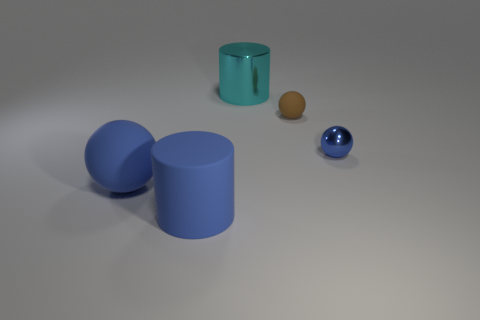There is a rubber object that is the same color as the rubber cylinder; what is its shape?
Provide a short and direct response. Sphere. The blue matte object that is right of the blue thing that is left of the big blue rubber cylinder is what shape?
Provide a succinct answer. Cylinder. Is there anything else that is the same color as the tiny rubber object?
Your answer should be very brief. No. Is the color of the small shiny ball the same as the large rubber ball?
Make the answer very short. Yes. How many green objects are either metallic spheres or big rubber things?
Offer a terse response. 0. Are there fewer metal things that are behind the brown ball than big cylinders?
Your response must be concise. Yes. There is a small sphere that is to the left of the small metallic thing; how many large blue rubber objects are in front of it?
Your answer should be very brief. 2. What number of other objects are the same size as the blue cylinder?
Provide a short and direct response. 2. How many things are either small green matte blocks or matte objects behind the blue rubber cylinder?
Provide a short and direct response. 2. Are there fewer cyan metallic objects than blue things?
Provide a succinct answer. Yes. 